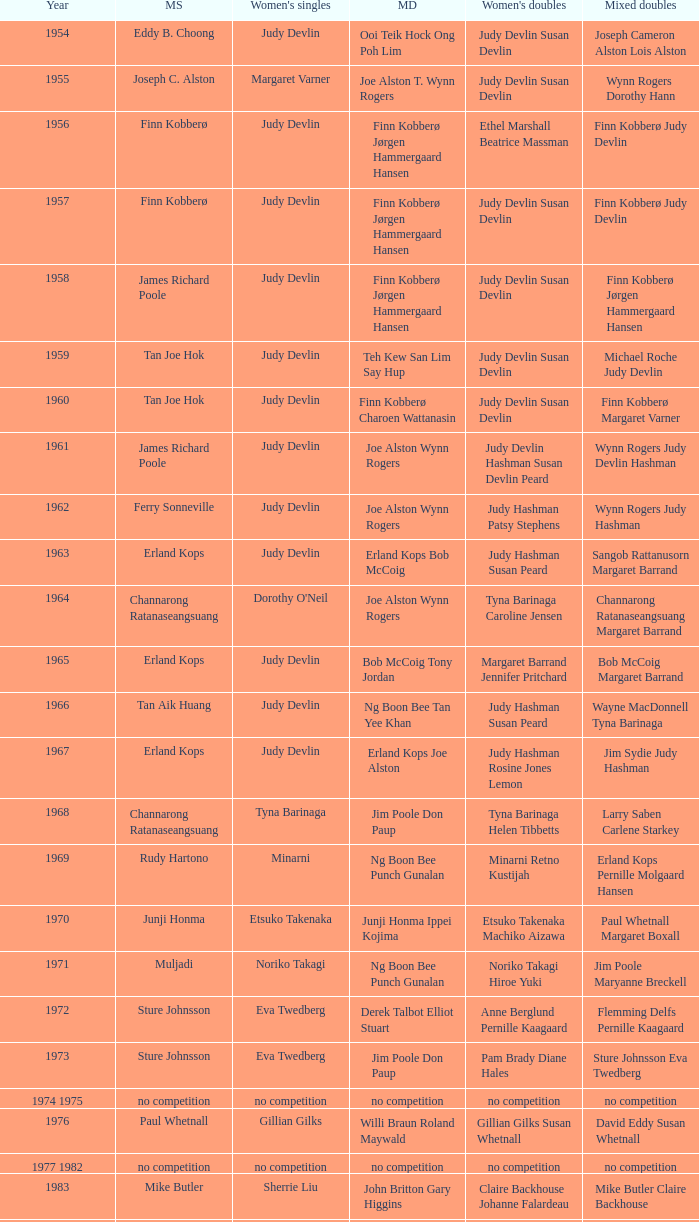Who were the men's doubles champions when the men's singles champion was muljadi? Ng Boon Bee Punch Gunalan. 